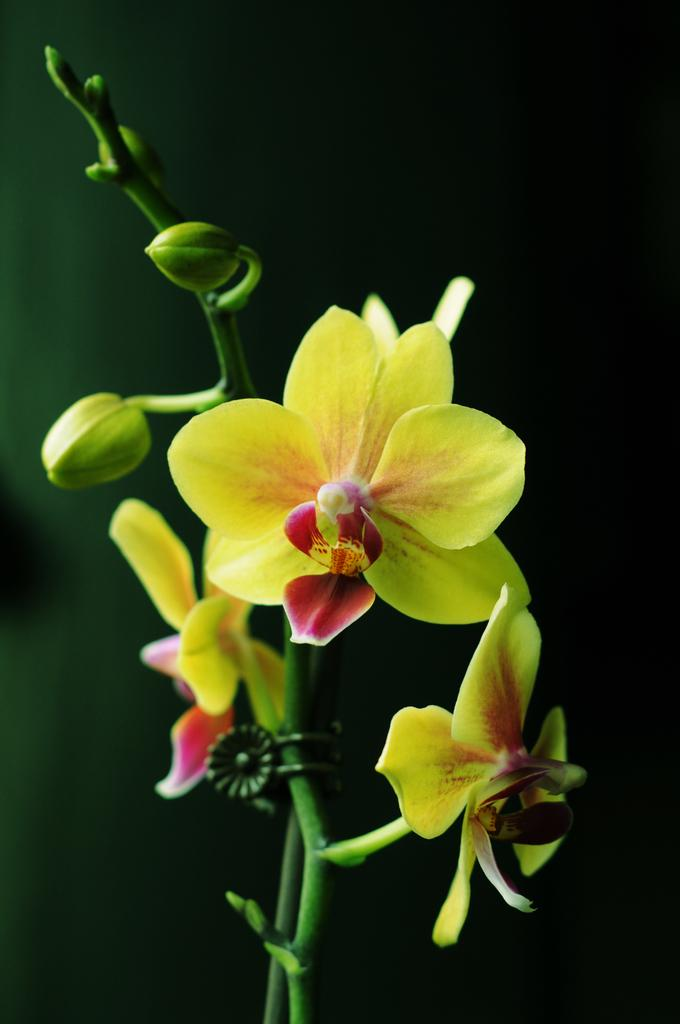What type of living organisms can be seen in the image? There are flowers in the image. What are the flowers growing on? The flowers are on plants. What colors are the flowers? The flowers are in yellow and red colors. What is the color of the background in the image? The background of the image is black. What is your dad doing in the image? There is no person, including your dad, present in the image. The image only features flowers on plants with a black background. 